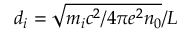<formula> <loc_0><loc_0><loc_500><loc_500>d _ { i } = \sqrt { m _ { i } c ^ { 2 } / { 4 \pi e ^ { 2 } n _ { 0 } } } / L</formula> 